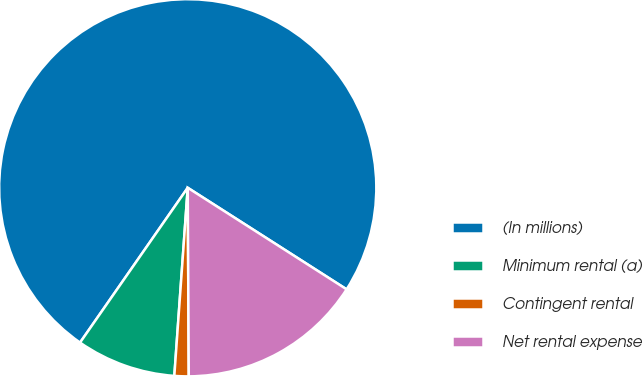<chart> <loc_0><loc_0><loc_500><loc_500><pie_chart><fcel>(In millions)<fcel>Minimum rental (a)<fcel>Contingent rental<fcel>Net rental expense<nl><fcel>74.38%<fcel>8.54%<fcel>1.22%<fcel>15.86%<nl></chart> 